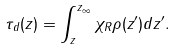<formula> <loc_0><loc_0><loc_500><loc_500>\tau _ { d } ( z ) = \int _ { z } ^ { z _ { \infty } } \chi _ { R } \rho ( z ^ { \prime } ) d z ^ { \prime } .</formula> 